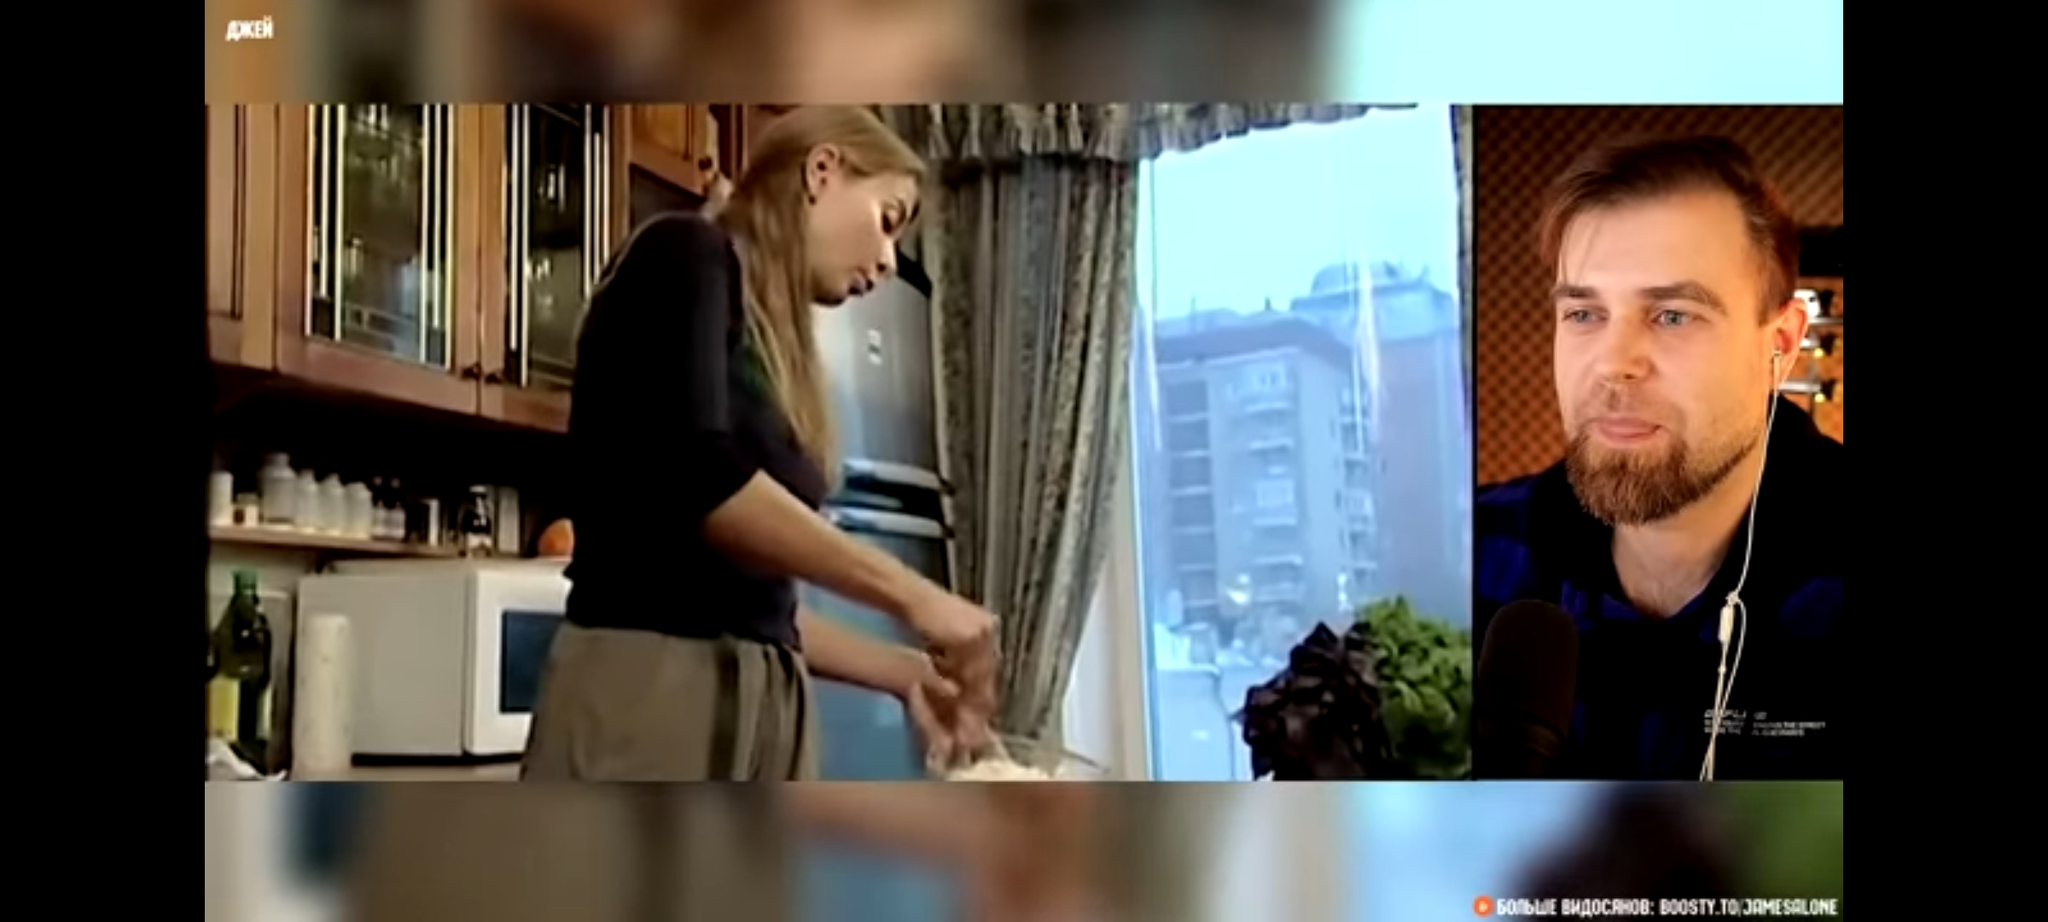Find the address of the building in the window (guess as close as you can) Based on the Cyrillic writing on the sign in the window, this is likely Russia. The window appears to be in a residential building, and the address would likely be something like "123 Ulitsa Lomonosova, Moscow, Russia". 